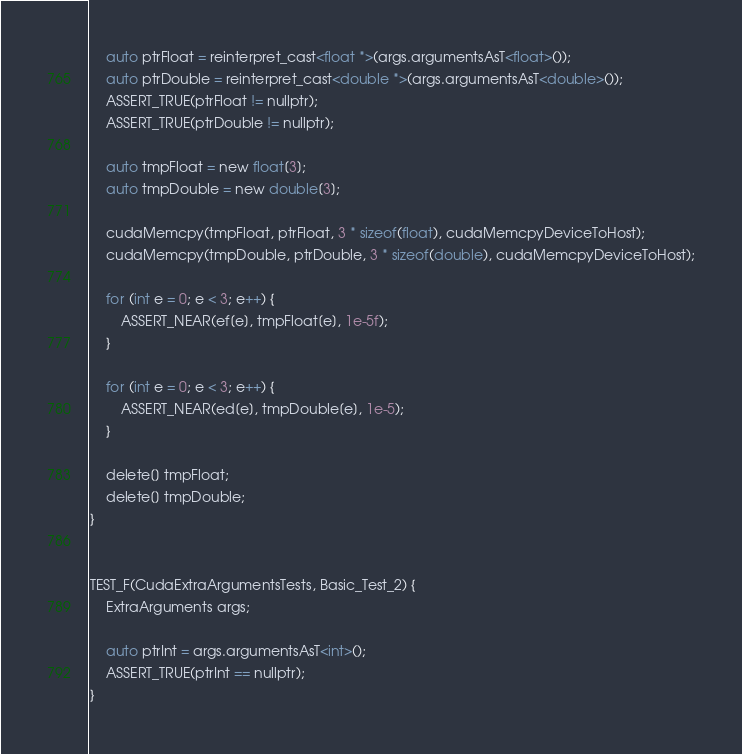Convert code to text. <code><loc_0><loc_0><loc_500><loc_500><_Cuda_>
    auto ptrFloat = reinterpret_cast<float *>(args.argumentsAsT<float>());
    auto ptrDouble = reinterpret_cast<double *>(args.argumentsAsT<double>());
    ASSERT_TRUE(ptrFloat != nullptr);
    ASSERT_TRUE(ptrDouble != nullptr);

    auto tmpFloat = new float[3];
    auto tmpDouble = new double[3];

    cudaMemcpy(tmpFloat, ptrFloat, 3 * sizeof(float), cudaMemcpyDeviceToHost);
    cudaMemcpy(tmpDouble, ptrDouble, 3 * sizeof(double), cudaMemcpyDeviceToHost);

    for (int e = 0; e < 3; e++) {
        ASSERT_NEAR(ef[e], tmpFloat[e], 1e-5f);
    }

    for (int e = 0; e < 3; e++) {
        ASSERT_NEAR(ed[e], tmpDouble[e], 1e-5);
    }

    delete[] tmpFloat;
    delete[] tmpDouble;
}


TEST_F(CudaExtraArgumentsTests, Basic_Test_2) {
    ExtraArguments args;

    auto ptrInt = args.argumentsAsT<int>();
    ASSERT_TRUE(ptrInt == nullptr);
}

</code> 